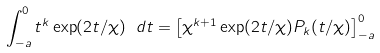Convert formula to latex. <formula><loc_0><loc_0><loc_500><loc_500>\int _ { - a } ^ { 0 } t ^ { k } \exp ( 2 t / \chi ) \ d t = \left [ \chi ^ { k + 1 } \exp ( 2 t / \chi ) P _ { k } ( t / \chi ) \right ] ^ { 0 } _ { - a }</formula> 